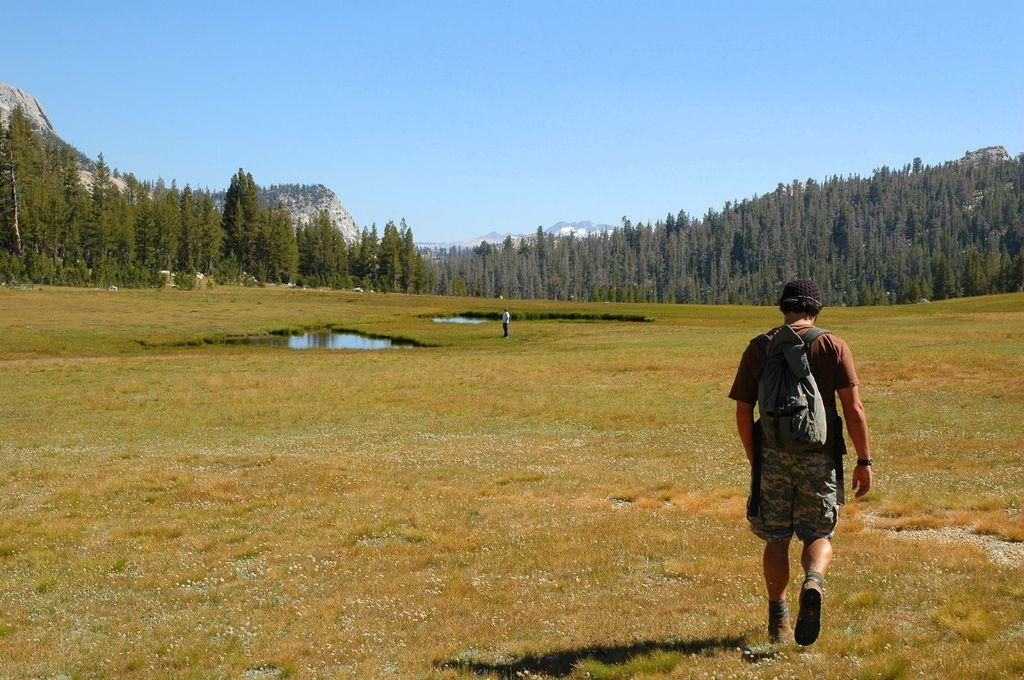What type of terrain is visible in the foreground of the image? There is grass and water bodies in the foreground of the image. How many people can be seen in the foreground of the image? There are two persons in the foreground of the image. What geographical features are located in the middle of the image? There are mountains and trees in the middle of the image. What part of the natural environment is visible at the top of the image? The sky is visible at the top of the image. What type of cushion is being used by the mountains in the image? There are no cushions present in the image, as the mountains are geographical features and not objects that can use cushions. 